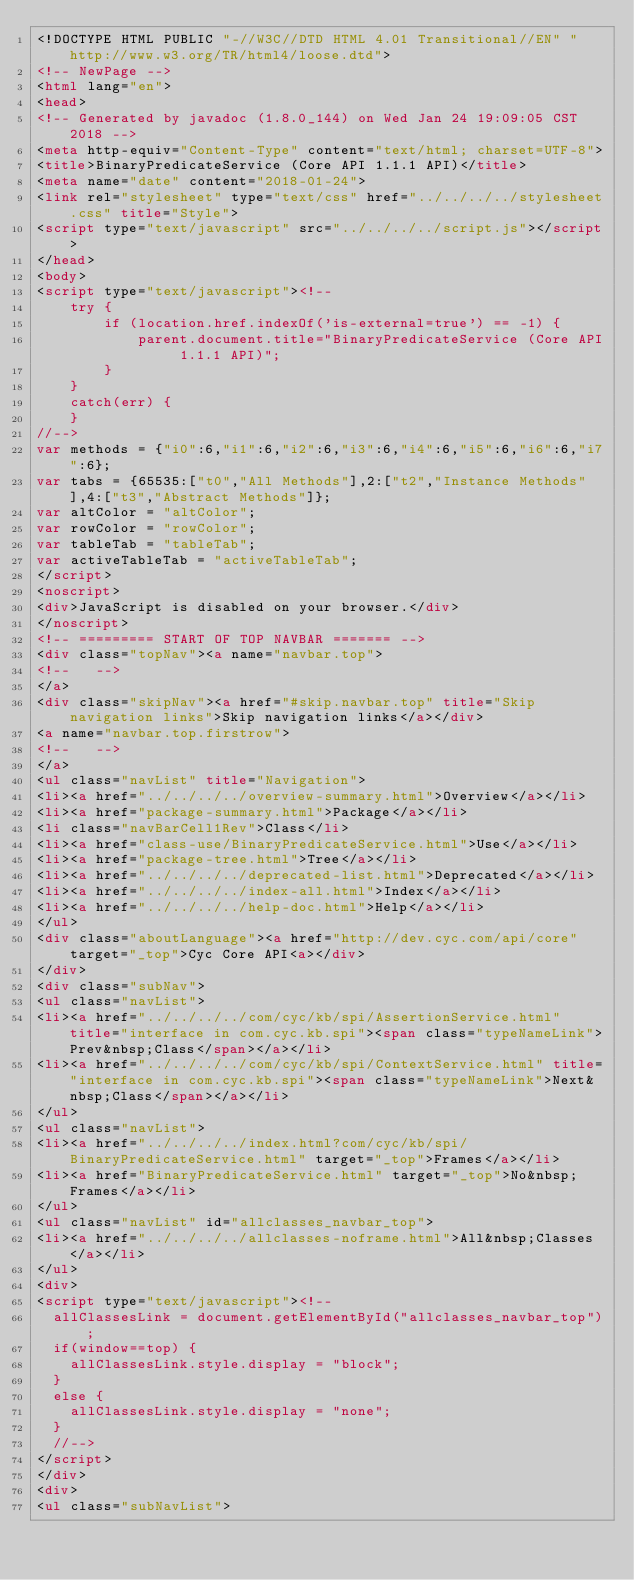Convert code to text. <code><loc_0><loc_0><loc_500><loc_500><_HTML_><!DOCTYPE HTML PUBLIC "-//W3C//DTD HTML 4.01 Transitional//EN" "http://www.w3.org/TR/html4/loose.dtd">
<!-- NewPage -->
<html lang="en">
<head>
<!-- Generated by javadoc (1.8.0_144) on Wed Jan 24 19:09:05 CST 2018 -->
<meta http-equiv="Content-Type" content="text/html; charset=UTF-8">
<title>BinaryPredicateService (Core API 1.1.1 API)</title>
<meta name="date" content="2018-01-24">
<link rel="stylesheet" type="text/css" href="../../../../stylesheet.css" title="Style">
<script type="text/javascript" src="../../../../script.js"></script>
</head>
<body>
<script type="text/javascript"><!--
    try {
        if (location.href.indexOf('is-external=true') == -1) {
            parent.document.title="BinaryPredicateService (Core API 1.1.1 API)";
        }
    }
    catch(err) {
    }
//-->
var methods = {"i0":6,"i1":6,"i2":6,"i3":6,"i4":6,"i5":6,"i6":6,"i7":6};
var tabs = {65535:["t0","All Methods"],2:["t2","Instance Methods"],4:["t3","Abstract Methods"]};
var altColor = "altColor";
var rowColor = "rowColor";
var tableTab = "tableTab";
var activeTableTab = "activeTableTab";
</script>
<noscript>
<div>JavaScript is disabled on your browser.</div>
</noscript>
<!-- ========= START OF TOP NAVBAR ======= -->
<div class="topNav"><a name="navbar.top">
<!--   -->
</a>
<div class="skipNav"><a href="#skip.navbar.top" title="Skip navigation links">Skip navigation links</a></div>
<a name="navbar.top.firstrow">
<!--   -->
</a>
<ul class="navList" title="Navigation">
<li><a href="../../../../overview-summary.html">Overview</a></li>
<li><a href="package-summary.html">Package</a></li>
<li class="navBarCell1Rev">Class</li>
<li><a href="class-use/BinaryPredicateService.html">Use</a></li>
<li><a href="package-tree.html">Tree</a></li>
<li><a href="../../../../deprecated-list.html">Deprecated</a></li>
<li><a href="../../../../index-all.html">Index</a></li>
<li><a href="../../../../help-doc.html">Help</a></li>
</ul>
<div class="aboutLanguage"><a href="http://dev.cyc.com/api/core" target="_top">Cyc Core API<a></div>
</div>
<div class="subNav">
<ul class="navList">
<li><a href="../../../../com/cyc/kb/spi/AssertionService.html" title="interface in com.cyc.kb.spi"><span class="typeNameLink">Prev&nbsp;Class</span></a></li>
<li><a href="../../../../com/cyc/kb/spi/ContextService.html" title="interface in com.cyc.kb.spi"><span class="typeNameLink">Next&nbsp;Class</span></a></li>
</ul>
<ul class="navList">
<li><a href="../../../../index.html?com/cyc/kb/spi/BinaryPredicateService.html" target="_top">Frames</a></li>
<li><a href="BinaryPredicateService.html" target="_top">No&nbsp;Frames</a></li>
</ul>
<ul class="navList" id="allclasses_navbar_top">
<li><a href="../../../../allclasses-noframe.html">All&nbsp;Classes</a></li>
</ul>
<div>
<script type="text/javascript"><!--
  allClassesLink = document.getElementById("allclasses_navbar_top");
  if(window==top) {
    allClassesLink.style.display = "block";
  }
  else {
    allClassesLink.style.display = "none";
  }
  //-->
</script>
</div>
<div>
<ul class="subNavList"></code> 